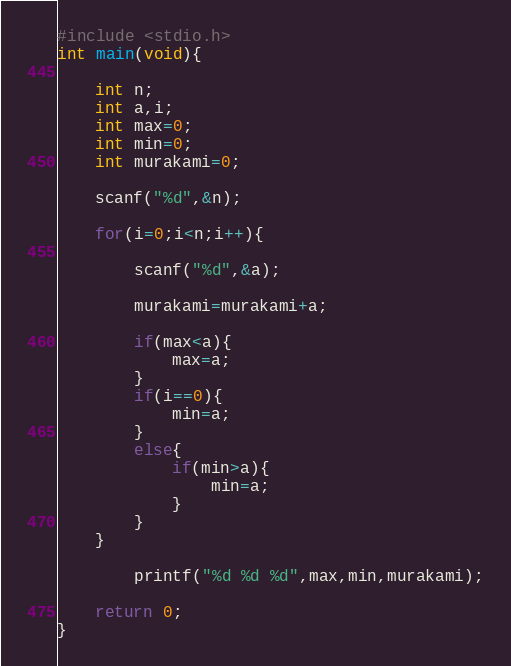Convert code to text. <code><loc_0><loc_0><loc_500><loc_500><_C_>#include <stdio.h>
int main(void){
	
	int n;
	int a,i;
	int max=0;
	int min=0;
	int murakami=0;
	
	scanf("%d",&n);
	
	for(i=0;i<n;i++){
		
		scanf("%d",&a);
		
		murakami=murakami+a;
		
		if(max<a){
			max=a;
		}
		if(i==0){
			min=a;
		}
		else{
			if(min>a){
				min=a;
			}
		}
	}
		
		printf("%d %d %d",max,min,murakami);
	
	return 0;
}</code> 